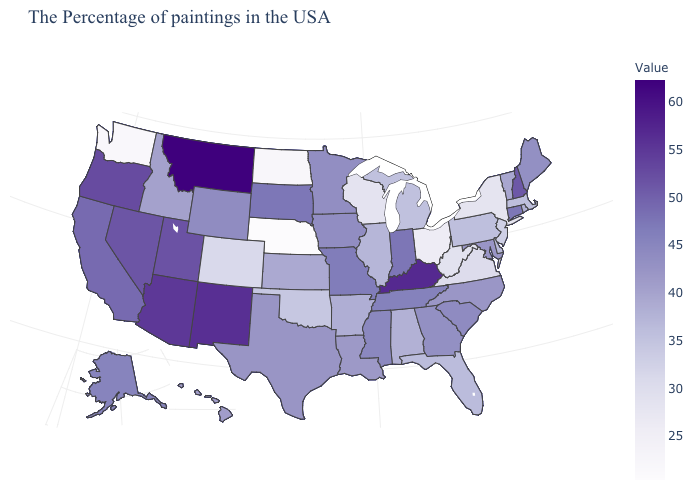Among the states that border Arizona , does New Mexico have the highest value?
Quick response, please. Yes. Among the states that border Pennsylvania , does Maryland have the highest value?
Answer briefly. Yes. Does the map have missing data?
Short answer required. No. Does Nebraska have the lowest value in the USA?
Give a very brief answer. Yes. Does Montana have the highest value in the USA?
Quick response, please. Yes. Does Ohio have a lower value than Nebraska?
Quick response, please. No. Does New Jersey have a higher value than Minnesota?
Answer briefly. No. Among the states that border Iowa , does South Dakota have the highest value?
Be succinct. Yes. Among the states that border Mississippi , which have the highest value?
Give a very brief answer. Tennessee. 